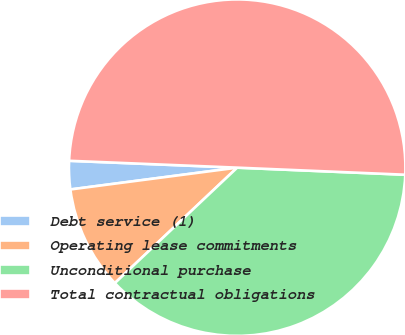Convert chart to OTSL. <chart><loc_0><loc_0><loc_500><loc_500><pie_chart><fcel>Debt service (1)<fcel>Operating lease commitments<fcel>Unconditional purchase<fcel>Total contractual obligations<nl><fcel>2.72%<fcel>9.97%<fcel>37.29%<fcel>50.02%<nl></chart> 